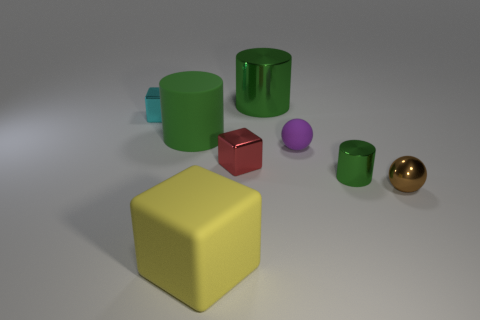There is a green rubber thing; are there any big shiny objects in front of it?
Provide a succinct answer. No. Is the number of small metallic objects that are to the right of the purple ball the same as the number of tiny purple rubber objects that are in front of the red metallic block?
Make the answer very short. No. There is a green metallic object that is in front of the tiny purple sphere; does it have the same size as the cylinder behind the matte cylinder?
Give a very brief answer. No. The thing that is in front of the small sphere that is to the right of the tiny ball that is left of the small brown metallic thing is what shape?
Provide a short and direct response. Cube. Is there anything else that has the same material as the small brown sphere?
Provide a succinct answer. Yes. The other thing that is the same shape as the small purple rubber object is what size?
Give a very brief answer. Small. There is a thing that is behind the small brown metal sphere and in front of the red metallic thing; what color is it?
Your answer should be very brief. Green. Are the red cube and the big green cylinder behind the large green rubber cylinder made of the same material?
Keep it short and to the point. Yes. Is the number of tiny green metallic things to the left of the rubber block less than the number of purple objects?
Keep it short and to the point. Yes. How many other things are there of the same shape as the brown object?
Your answer should be very brief. 1. 